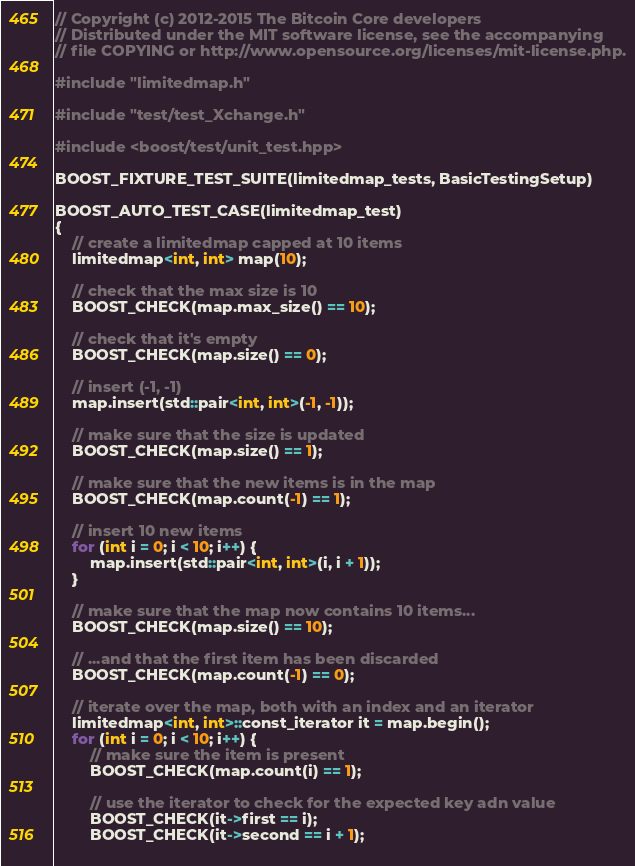<code> <loc_0><loc_0><loc_500><loc_500><_C++_>// Copyright (c) 2012-2015 The Bitcoin Core developers
// Distributed under the MIT software license, see the accompanying
// file COPYING or http://www.opensource.org/licenses/mit-license.php.

#include "limitedmap.h"

#include "test/test_Xchange.h"

#include <boost/test/unit_test.hpp>

BOOST_FIXTURE_TEST_SUITE(limitedmap_tests, BasicTestingSetup)

BOOST_AUTO_TEST_CASE(limitedmap_test)
{
    // create a limitedmap capped at 10 items
    limitedmap<int, int> map(10);

    // check that the max size is 10
    BOOST_CHECK(map.max_size() == 10);

    // check that it's empty
    BOOST_CHECK(map.size() == 0);

    // insert (-1, -1)
    map.insert(std::pair<int, int>(-1, -1));

    // make sure that the size is updated
    BOOST_CHECK(map.size() == 1);

    // make sure that the new items is in the map
    BOOST_CHECK(map.count(-1) == 1);

    // insert 10 new items
    for (int i = 0; i < 10; i++) {
        map.insert(std::pair<int, int>(i, i + 1));
    }

    // make sure that the map now contains 10 items...
    BOOST_CHECK(map.size() == 10);

    // ...and that the first item has been discarded
    BOOST_CHECK(map.count(-1) == 0);

    // iterate over the map, both with an index and an iterator
    limitedmap<int, int>::const_iterator it = map.begin();
    for (int i = 0; i < 10; i++) {
        // make sure the item is present
        BOOST_CHECK(map.count(i) == 1);

        // use the iterator to check for the expected key adn value
        BOOST_CHECK(it->first == i);
        BOOST_CHECK(it->second == i + 1);
        </code> 